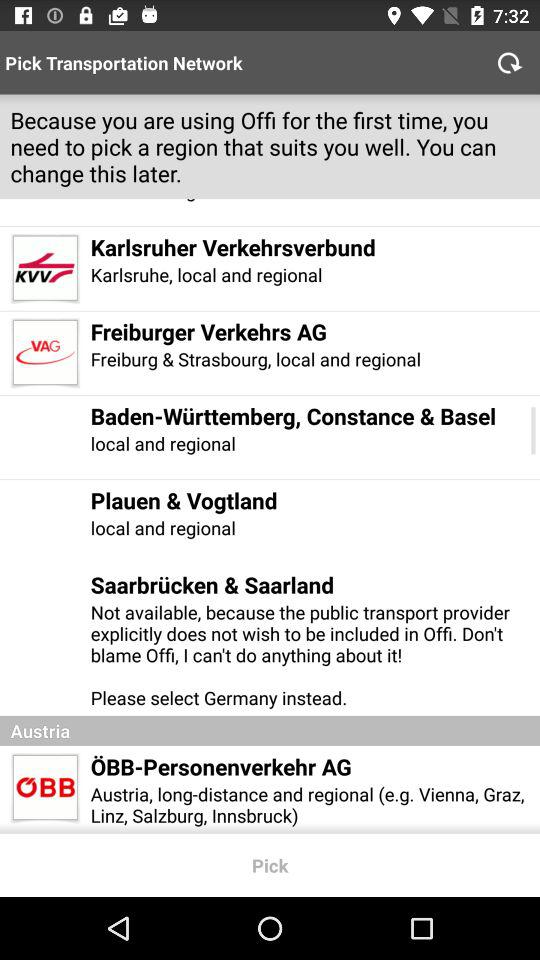How many transportation networks are available in Austria?
Answer the question using a single word or phrase. 1 